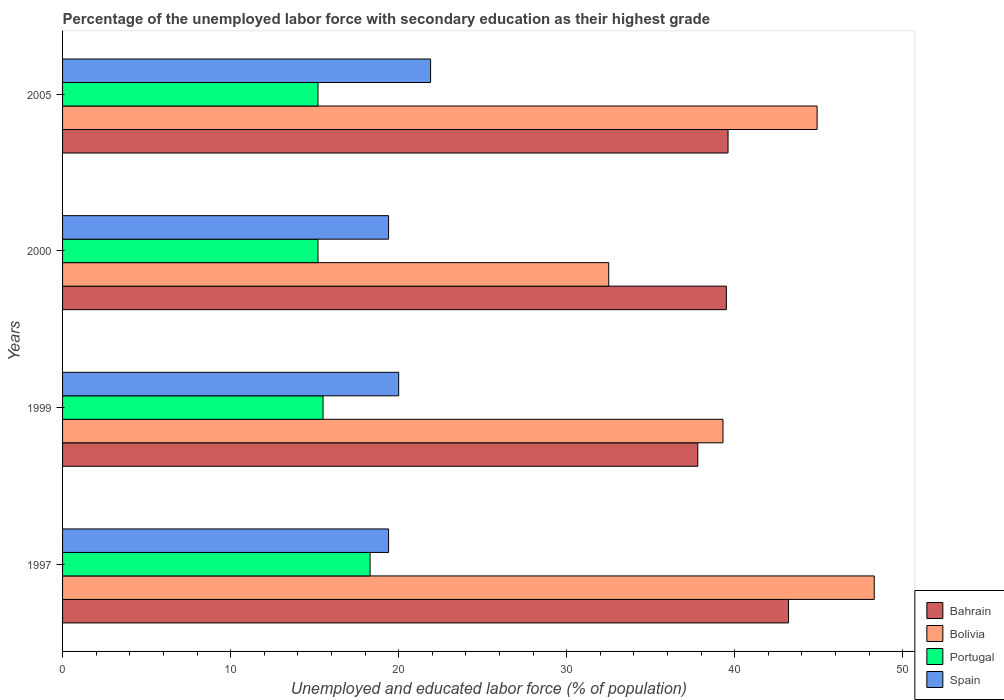How many groups of bars are there?
Your answer should be very brief. 4. Are the number of bars per tick equal to the number of legend labels?
Keep it short and to the point. Yes. Are the number of bars on each tick of the Y-axis equal?
Give a very brief answer. Yes. How many bars are there on the 2nd tick from the top?
Make the answer very short. 4. What is the label of the 3rd group of bars from the top?
Give a very brief answer. 1999. In how many cases, is the number of bars for a given year not equal to the number of legend labels?
Your answer should be compact. 0. What is the percentage of the unemployed labor force with secondary education in Portugal in 1997?
Your answer should be very brief. 18.3. Across all years, what is the maximum percentage of the unemployed labor force with secondary education in Bahrain?
Give a very brief answer. 43.2. Across all years, what is the minimum percentage of the unemployed labor force with secondary education in Portugal?
Make the answer very short. 15.2. In which year was the percentage of the unemployed labor force with secondary education in Bolivia minimum?
Offer a very short reply. 2000. What is the total percentage of the unemployed labor force with secondary education in Bolivia in the graph?
Make the answer very short. 165. What is the difference between the percentage of the unemployed labor force with secondary education in Bolivia in 1999 and that in 2005?
Make the answer very short. -5.6. What is the difference between the percentage of the unemployed labor force with secondary education in Bahrain in 2005 and the percentage of the unemployed labor force with secondary education in Bolivia in 1999?
Make the answer very short. 0.3. What is the average percentage of the unemployed labor force with secondary education in Bolivia per year?
Your answer should be compact. 41.25. In the year 1997, what is the difference between the percentage of the unemployed labor force with secondary education in Spain and percentage of the unemployed labor force with secondary education in Portugal?
Your answer should be very brief. 1.1. In how many years, is the percentage of the unemployed labor force with secondary education in Portugal greater than 4 %?
Offer a very short reply. 4. What is the ratio of the percentage of the unemployed labor force with secondary education in Bolivia in 1997 to that in 2000?
Offer a very short reply. 1.49. Is the difference between the percentage of the unemployed labor force with secondary education in Spain in 1997 and 1999 greater than the difference between the percentage of the unemployed labor force with secondary education in Portugal in 1997 and 1999?
Ensure brevity in your answer.  No. What is the difference between the highest and the second highest percentage of the unemployed labor force with secondary education in Bahrain?
Your response must be concise. 3.6. What is the difference between the highest and the lowest percentage of the unemployed labor force with secondary education in Bahrain?
Your answer should be very brief. 5.4. In how many years, is the percentage of the unemployed labor force with secondary education in Bahrain greater than the average percentage of the unemployed labor force with secondary education in Bahrain taken over all years?
Offer a very short reply. 1. What does the 4th bar from the top in 2005 represents?
Provide a succinct answer. Bahrain. Are all the bars in the graph horizontal?
Offer a very short reply. Yes. How many years are there in the graph?
Your response must be concise. 4. Are the values on the major ticks of X-axis written in scientific E-notation?
Make the answer very short. No. Does the graph contain any zero values?
Offer a terse response. No. Where does the legend appear in the graph?
Offer a terse response. Bottom right. What is the title of the graph?
Your answer should be compact. Percentage of the unemployed labor force with secondary education as their highest grade. Does "Ghana" appear as one of the legend labels in the graph?
Keep it short and to the point. No. What is the label or title of the X-axis?
Keep it short and to the point. Unemployed and educated labor force (% of population). What is the label or title of the Y-axis?
Ensure brevity in your answer.  Years. What is the Unemployed and educated labor force (% of population) of Bahrain in 1997?
Offer a terse response. 43.2. What is the Unemployed and educated labor force (% of population) in Bolivia in 1997?
Offer a terse response. 48.3. What is the Unemployed and educated labor force (% of population) of Portugal in 1997?
Your answer should be compact. 18.3. What is the Unemployed and educated labor force (% of population) of Spain in 1997?
Give a very brief answer. 19.4. What is the Unemployed and educated labor force (% of population) in Bahrain in 1999?
Your answer should be compact. 37.8. What is the Unemployed and educated labor force (% of population) in Bolivia in 1999?
Ensure brevity in your answer.  39.3. What is the Unemployed and educated labor force (% of population) in Portugal in 1999?
Your answer should be compact. 15.5. What is the Unemployed and educated labor force (% of population) in Spain in 1999?
Make the answer very short. 20. What is the Unemployed and educated labor force (% of population) in Bahrain in 2000?
Your response must be concise. 39.5. What is the Unemployed and educated labor force (% of population) of Bolivia in 2000?
Your answer should be compact. 32.5. What is the Unemployed and educated labor force (% of population) in Portugal in 2000?
Provide a short and direct response. 15.2. What is the Unemployed and educated labor force (% of population) of Spain in 2000?
Keep it short and to the point. 19.4. What is the Unemployed and educated labor force (% of population) of Bahrain in 2005?
Your response must be concise. 39.6. What is the Unemployed and educated labor force (% of population) of Bolivia in 2005?
Provide a succinct answer. 44.9. What is the Unemployed and educated labor force (% of population) in Portugal in 2005?
Make the answer very short. 15.2. What is the Unemployed and educated labor force (% of population) of Spain in 2005?
Provide a succinct answer. 21.9. Across all years, what is the maximum Unemployed and educated labor force (% of population) of Bahrain?
Your answer should be very brief. 43.2. Across all years, what is the maximum Unemployed and educated labor force (% of population) of Bolivia?
Offer a very short reply. 48.3. Across all years, what is the maximum Unemployed and educated labor force (% of population) of Portugal?
Your response must be concise. 18.3. Across all years, what is the maximum Unemployed and educated labor force (% of population) of Spain?
Ensure brevity in your answer.  21.9. Across all years, what is the minimum Unemployed and educated labor force (% of population) in Bahrain?
Your answer should be compact. 37.8. Across all years, what is the minimum Unemployed and educated labor force (% of population) of Bolivia?
Ensure brevity in your answer.  32.5. Across all years, what is the minimum Unemployed and educated labor force (% of population) of Portugal?
Your response must be concise. 15.2. Across all years, what is the minimum Unemployed and educated labor force (% of population) of Spain?
Your answer should be compact. 19.4. What is the total Unemployed and educated labor force (% of population) in Bahrain in the graph?
Your answer should be compact. 160.1. What is the total Unemployed and educated labor force (% of population) in Bolivia in the graph?
Provide a short and direct response. 165. What is the total Unemployed and educated labor force (% of population) in Portugal in the graph?
Your answer should be compact. 64.2. What is the total Unemployed and educated labor force (% of population) in Spain in the graph?
Ensure brevity in your answer.  80.7. What is the difference between the Unemployed and educated labor force (% of population) of Bahrain in 1997 and that in 1999?
Offer a terse response. 5.4. What is the difference between the Unemployed and educated labor force (% of population) in Spain in 1997 and that in 1999?
Give a very brief answer. -0.6. What is the difference between the Unemployed and educated labor force (% of population) of Bolivia in 1997 and that in 2000?
Make the answer very short. 15.8. What is the difference between the Unemployed and educated labor force (% of population) in Portugal in 1997 and that in 2000?
Ensure brevity in your answer.  3.1. What is the difference between the Unemployed and educated labor force (% of population) of Bahrain in 1997 and that in 2005?
Offer a terse response. 3.6. What is the difference between the Unemployed and educated labor force (% of population) in Bolivia in 1997 and that in 2005?
Your answer should be very brief. 3.4. What is the difference between the Unemployed and educated labor force (% of population) in Spain in 1997 and that in 2005?
Offer a very short reply. -2.5. What is the difference between the Unemployed and educated labor force (% of population) in Bolivia in 1999 and that in 2000?
Provide a short and direct response. 6.8. What is the difference between the Unemployed and educated labor force (% of population) of Portugal in 1999 and that in 2000?
Provide a succinct answer. 0.3. What is the difference between the Unemployed and educated labor force (% of population) in Spain in 1999 and that in 2000?
Give a very brief answer. 0.6. What is the difference between the Unemployed and educated labor force (% of population) of Bahrain in 1999 and that in 2005?
Keep it short and to the point. -1.8. What is the difference between the Unemployed and educated labor force (% of population) in Bolivia in 1999 and that in 2005?
Give a very brief answer. -5.6. What is the difference between the Unemployed and educated labor force (% of population) in Spain in 1999 and that in 2005?
Provide a short and direct response. -1.9. What is the difference between the Unemployed and educated labor force (% of population) in Bolivia in 2000 and that in 2005?
Your response must be concise. -12.4. What is the difference between the Unemployed and educated labor force (% of population) of Portugal in 2000 and that in 2005?
Ensure brevity in your answer.  0. What is the difference between the Unemployed and educated labor force (% of population) in Bahrain in 1997 and the Unemployed and educated labor force (% of population) in Portugal in 1999?
Ensure brevity in your answer.  27.7. What is the difference between the Unemployed and educated labor force (% of population) of Bahrain in 1997 and the Unemployed and educated labor force (% of population) of Spain in 1999?
Provide a succinct answer. 23.2. What is the difference between the Unemployed and educated labor force (% of population) in Bolivia in 1997 and the Unemployed and educated labor force (% of population) in Portugal in 1999?
Make the answer very short. 32.8. What is the difference between the Unemployed and educated labor force (% of population) in Bolivia in 1997 and the Unemployed and educated labor force (% of population) in Spain in 1999?
Your response must be concise. 28.3. What is the difference between the Unemployed and educated labor force (% of population) in Portugal in 1997 and the Unemployed and educated labor force (% of population) in Spain in 1999?
Give a very brief answer. -1.7. What is the difference between the Unemployed and educated labor force (% of population) of Bahrain in 1997 and the Unemployed and educated labor force (% of population) of Spain in 2000?
Ensure brevity in your answer.  23.8. What is the difference between the Unemployed and educated labor force (% of population) in Bolivia in 1997 and the Unemployed and educated labor force (% of population) in Portugal in 2000?
Offer a terse response. 33.1. What is the difference between the Unemployed and educated labor force (% of population) of Bolivia in 1997 and the Unemployed and educated labor force (% of population) of Spain in 2000?
Offer a terse response. 28.9. What is the difference between the Unemployed and educated labor force (% of population) of Portugal in 1997 and the Unemployed and educated labor force (% of population) of Spain in 2000?
Ensure brevity in your answer.  -1.1. What is the difference between the Unemployed and educated labor force (% of population) of Bahrain in 1997 and the Unemployed and educated labor force (% of population) of Bolivia in 2005?
Offer a very short reply. -1.7. What is the difference between the Unemployed and educated labor force (% of population) of Bahrain in 1997 and the Unemployed and educated labor force (% of population) of Spain in 2005?
Offer a terse response. 21.3. What is the difference between the Unemployed and educated labor force (% of population) of Bolivia in 1997 and the Unemployed and educated labor force (% of population) of Portugal in 2005?
Make the answer very short. 33.1. What is the difference between the Unemployed and educated labor force (% of population) in Bolivia in 1997 and the Unemployed and educated labor force (% of population) in Spain in 2005?
Your response must be concise. 26.4. What is the difference between the Unemployed and educated labor force (% of population) in Portugal in 1997 and the Unemployed and educated labor force (% of population) in Spain in 2005?
Make the answer very short. -3.6. What is the difference between the Unemployed and educated labor force (% of population) of Bahrain in 1999 and the Unemployed and educated labor force (% of population) of Bolivia in 2000?
Give a very brief answer. 5.3. What is the difference between the Unemployed and educated labor force (% of population) of Bahrain in 1999 and the Unemployed and educated labor force (% of population) of Portugal in 2000?
Your response must be concise. 22.6. What is the difference between the Unemployed and educated labor force (% of population) of Bolivia in 1999 and the Unemployed and educated labor force (% of population) of Portugal in 2000?
Offer a terse response. 24.1. What is the difference between the Unemployed and educated labor force (% of population) in Portugal in 1999 and the Unemployed and educated labor force (% of population) in Spain in 2000?
Keep it short and to the point. -3.9. What is the difference between the Unemployed and educated labor force (% of population) of Bahrain in 1999 and the Unemployed and educated labor force (% of population) of Portugal in 2005?
Your response must be concise. 22.6. What is the difference between the Unemployed and educated labor force (% of population) of Bolivia in 1999 and the Unemployed and educated labor force (% of population) of Portugal in 2005?
Provide a succinct answer. 24.1. What is the difference between the Unemployed and educated labor force (% of population) of Bolivia in 1999 and the Unemployed and educated labor force (% of population) of Spain in 2005?
Offer a terse response. 17.4. What is the difference between the Unemployed and educated labor force (% of population) of Bahrain in 2000 and the Unemployed and educated labor force (% of population) of Portugal in 2005?
Provide a succinct answer. 24.3. What is the difference between the Unemployed and educated labor force (% of population) in Bahrain in 2000 and the Unemployed and educated labor force (% of population) in Spain in 2005?
Provide a short and direct response. 17.6. What is the difference between the Unemployed and educated labor force (% of population) of Portugal in 2000 and the Unemployed and educated labor force (% of population) of Spain in 2005?
Give a very brief answer. -6.7. What is the average Unemployed and educated labor force (% of population) in Bahrain per year?
Provide a short and direct response. 40.02. What is the average Unemployed and educated labor force (% of population) of Bolivia per year?
Make the answer very short. 41.25. What is the average Unemployed and educated labor force (% of population) in Portugal per year?
Your answer should be compact. 16.05. What is the average Unemployed and educated labor force (% of population) in Spain per year?
Your answer should be very brief. 20.18. In the year 1997, what is the difference between the Unemployed and educated labor force (% of population) in Bahrain and Unemployed and educated labor force (% of population) in Bolivia?
Your response must be concise. -5.1. In the year 1997, what is the difference between the Unemployed and educated labor force (% of population) in Bahrain and Unemployed and educated labor force (% of population) in Portugal?
Keep it short and to the point. 24.9. In the year 1997, what is the difference between the Unemployed and educated labor force (% of population) in Bahrain and Unemployed and educated labor force (% of population) in Spain?
Your answer should be very brief. 23.8. In the year 1997, what is the difference between the Unemployed and educated labor force (% of population) of Bolivia and Unemployed and educated labor force (% of population) of Spain?
Offer a terse response. 28.9. In the year 1999, what is the difference between the Unemployed and educated labor force (% of population) of Bahrain and Unemployed and educated labor force (% of population) of Bolivia?
Give a very brief answer. -1.5. In the year 1999, what is the difference between the Unemployed and educated labor force (% of population) of Bahrain and Unemployed and educated labor force (% of population) of Portugal?
Provide a succinct answer. 22.3. In the year 1999, what is the difference between the Unemployed and educated labor force (% of population) of Bahrain and Unemployed and educated labor force (% of population) of Spain?
Offer a terse response. 17.8. In the year 1999, what is the difference between the Unemployed and educated labor force (% of population) in Bolivia and Unemployed and educated labor force (% of population) in Portugal?
Your answer should be very brief. 23.8. In the year 1999, what is the difference between the Unemployed and educated labor force (% of population) of Bolivia and Unemployed and educated labor force (% of population) of Spain?
Give a very brief answer. 19.3. In the year 2000, what is the difference between the Unemployed and educated labor force (% of population) of Bahrain and Unemployed and educated labor force (% of population) of Bolivia?
Your answer should be compact. 7. In the year 2000, what is the difference between the Unemployed and educated labor force (% of population) of Bahrain and Unemployed and educated labor force (% of population) of Portugal?
Your response must be concise. 24.3. In the year 2000, what is the difference between the Unemployed and educated labor force (% of population) of Bahrain and Unemployed and educated labor force (% of population) of Spain?
Ensure brevity in your answer.  20.1. In the year 2005, what is the difference between the Unemployed and educated labor force (% of population) in Bahrain and Unemployed and educated labor force (% of population) in Portugal?
Make the answer very short. 24.4. In the year 2005, what is the difference between the Unemployed and educated labor force (% of population) in Bahrain and Unemployed and educated labor force (% of population) in Spain?
Your response must be concise. 17.7. In the year 2005, what is the difference between the Unemployed and educated labor force (% of population) of Bolivia and Unemployed and educated labor force (% of population) of Portugal?
Ensure brevity in your answer.  29.7. What is the ratio of the Unemployed and educated labor force (% of population) in Bolivia in 1997 to that in 1999?
Make the answer very short. 1.23. What is the ratio of the Unemployed and educated labor force (% of population) in Portugal in 1997 to that in 1999?
Provide a succinct answer. 1.18. What is the ratio of the Unemployed and educated labor force (% of population) of Bahrain in 1997 to that in 2000?
Your answer should be very brief. 1.09. What is the ratio of the Unemployed and educated labor force (% of population) in Bolivia in 1997 to that in 2000?
Your response must be concise. 1.49. What is the ratio of the Unemployed and educated labor force (% of population) of Portugal in 1997 to that in 2000?
Provide a succinct answer. 1.2. What is the ratio of the Unemployed and educated labor force (% of population) of Spain in 1997 to that in 2000?
Ensure brevity in your answer.  1. What is the ratio of the Unemployed and educated labor force (% of population) of Bahrain in 1997 to that in 2005?
Your answer should be very brief. 1.09. What is the ratio of the Unemployed and educated labor force (% of population) in Bolivia in 1997 to that in 2005?
Provide a short and direct response. 1.08. What is the ratio of the Unemployed and educated labor force (% of population) in Portugal in 1997 to that in 2005?
Offer a very short reply. 1.2. What is the ratio of the Unemployed and educated labor force (% of population) of Spain in 1997 to that in 2005?
Ensure brevity in your answer.  0.89. What is the ratio of the Unemployed and educated labor force (% of population) in Bolivia in 1999 to that in 2000?
Give a very brief answer. 1.21. What is the ratio of the Unemployed and educated labor force (% of population) of Portugal in 1999 to that in 2000?
Make the answer very short. 1.02. What is the ratio of the Unemployed and educated labor force (% of population) of Spain in 1999 to that in 2000?
Ensure brevity in your answer.  1.03. What is the ratio of the Unemployed and educated labor force (% of population) of Bahrain in 1999 to that in 2005?
Your answer should be compact. 0.95. What is the ratio of the Unemployed and educated labor force (% of population) in Bolivia in 1999 to that in 2005?
Make the answer very short. 0.88. What is the ratio of the Unemployed and educated labor force (% of population) in Portugal in 1999 to that in 2005?
Give a very brief answer. 1.02. What is the ratio of the Unemployed and educated labor force (% of population) in Spain in 1999 to that in 2005?
Your answer should be compact. 0.91. What is the ratio of the Unemployed and educated labor force (% of population) in Bolivia in 2000 to that in 2005?
Keep it short and to the point. 0.72. What is the ratio of the Unemployed and educated labor force (% of population) of Spain in 2000 to that in 2005?
Give a very brief answer. 0.89. What is the difference between the highest and the second highest Unemployed and educated labor force (% of population) in Bahrain?
Ensure brevity in your answer.  3.6. What is the difference between the highest and the second highest Unemployed and educated labor force (% of population) of Spain?
Keep it short and to the point. 1.9. What is the difference between the highest and the lowest Unemployed and educated labor force (% of population) in Spain?
Your response must be concise. 2.5. 